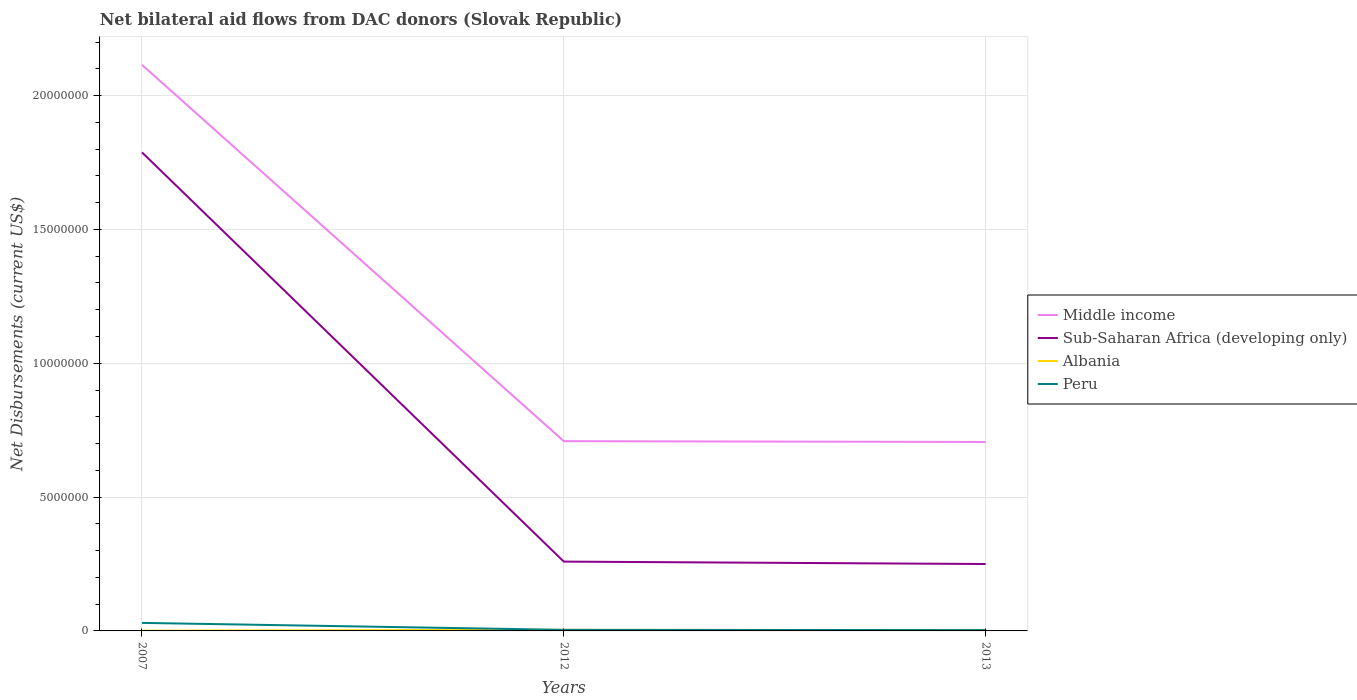How many different coloured lines are there?
Your answer should be very brief. 4. Does the line corresponding to Middle income intersect with the line corresponding to Peru?
Provide a short and direct response. No. Across all years, what is the maximum net bilateral aid flows in Sub-Saharan Africa (developing only)?
Make the answer very short. 2.50e+06. In which year was the net bilateral aid flows in Middle income maximum?
Provide a succinct answer. 2013. What is the total net bilateral aid flows in Peru in the graph?
Provide a short and direct response. 2.70e+05. What is the difference between the highest and the second highest net bilateral aid flows in Albania?
Ensure brevity in your answer.  3.00e+04. What is the difference between the highest and the lowest net bilateral aid flows in Sub-Saharan Africa (developing only)?
Provide a short and direct response. 1. How many years are there in the graph?
Your answer should be very brief. 3. Are the values on the major ticks of Y-axis written in scientific E-notation?
Offer a very short reply. No. Does the graph contain grids?
Your response must be concise. Yes. Where does the legend appear in the graph?
Offer a very short reply. Center right. How many legend labels are there?
Give a very brief answer. 4. How are the legend labels stacked?
Your response must be concise. Vertical. What is the title of the graph?
Provide a short and direct response. Net bilateral aid flows from DAC donors (Slovak Republic). What is the label or title of the X-axis?
Provide a succinct answer. Years. What is the label or title of the Y-axis?
Give a very brief answer. Net Disbursements (current US$). What is the Net Disbursements (current US$) in Middle income in 2007?
Provide a succinct answer. 2.12e+07. What is the Net Disbursements (current US$) of Sub-Saharan Africa (developing only) in 2007?
Provide a succinct answer. 1.79e+07. What is the Net Disbursements (current US$) in Peru in 2007?
Your answer should be compact. 3.00e+05. What is the Net Disbursements (current US$) of Middle income in 2012?
Offer a terse response. 7.09e+06. What is the Net Disbursements (current US$) of Sub-Saharan Africa (developing only) in 2012?
Your answer should be compact. 2.59e+06. What is the Net Disbursements (current US$) in Albania in 2012?
Provide a succinct answer. 4.00e+04. What is the Net Disbursements (current US$) of Middle income in 2013?
Offer a very short reply. 7.06e+06. What is the Net Disbursements (current US$) of Sub-Saharan Africa (developing only) in 2013?
Keep it short and to the point. 2.50e+06. Across all years, what is the maximum Net Disbursements (current US$) in Middle income?
Offer a very short reply. 2.12e+07. Across all years, what is the maximum Net Disbursements (current US$) of Sub-Saharan Africa (developing only)?
Offer a terse response. 1.79e+07. Across all years, what is the maximum Net Disbursements (current US$) of Peru?
Your response must be concise. 3.00e+05. Across all years, what is the minimum Net Disbursements (current US$) of Middle income?
Your answer should be compact. 7.06e+06. Across all years, what is the minimum Net Disbursements (current US$) of Sub-Saharan Africa (developing only)?
Your answer should be very brief. 2.50e+06. Across all years, what is the minimum Net Disbursements (current US$) of Albania?
Make the answer very short. 10000. What is the total Net Disbursements (current US$) in Middle income in the graph?
Provide a short and direct response. 3.53e+07. What is the total Net Disbursements (current US$) of Sub-Saharan Africa (developing only) in the graph?
Give a very brief answer. 2.30e+07. What is the total Net Disbursements (current US$) of Peru in the graph?
Offer a terse response. 3.70e+05. What is the difference between the Net Disbursements (current US$) of Middle income in 2007 and that in 2012?
Your response must be concise. 1.41e+07. What is the difference between the Net Disbursements (current US$) in Sub-Saharan Africa (developing only) in 2007 and that in 2012?
Offer a very short reply. 1.53e+07. What is the difference between the Net Disbursements (current US$) of Albania in 2007 and that in 2012?
Keep it short and to the point. -3.00e+04. What is the difference between the Net Disbursements (current US$) of Peru in 2007 and that in 2012?
Ensure brevity in your answer.  2.60e+05. What is the difference between the Net Disbursements (current US$) of Middle income in 2007 and that in 2013?
Ensure brevity in your answer.  1.41e+07. What is the difference between the Net Disbursements (current US$) of Sub-Saharan Africa (developing only) in 2007 and that in 2013?
Your response must be concise. 1.54e+07. What is the difference between the Net Disbursements (current US$) in Albania in 2007 and that in 2013?
Ensure brevity in your answer.  -2.00e+04. What is the difference between the Net Disbursements (current US$) in Peru in 2007 and that in 2013?
Your answer should be very brief. 2.70e+05. What is the difference between the Net Disbursements (current US$) of Middle income in 2012 and that in 2013?
Give a very brief answer. 3.00e+04. What is the difference between the Net Disbursements (current US$) in Middle income in 2007 and the Net Disbursements (current US$) in Sub-Saharan Africa (developing only) in 2012?
Provide a succinct answer. 1.86e+07. What is the difference between the Net Disbursements (current US$) of Middle income in 2007 and the Net Disbursements (current US$) of Albania in 2012?
Provide a short and direct response. 2.11e+07. What is the difference between the Net Disbursements (current US$) of Middle income in 2007 and the Net Disbursements (current US$) of Peru in 2012?
Your answer should be compact. 2.11e+07. What is the difference between the Net Disbursements (current US$) of Sub-Saharan Africa (developing only) in 2007 and the Net Disbursements (current US$) of Albania in 2012?
Your response must be concise. 1.78e+07. What is the difference between the Net Disbursements (current US$) of Sub-Saharan Africa (developing only) in 2007 and the Net Disbursements (current US$) of Peru in 2012?
Your response must be concise. 1.78e+07. What is the difference between the Net Disbursements (current US$) in Albania in 2007 and the Net Disbursements (current US$) in Peru in 2012?
Your response must be concise. -3.00e+04. What is the difference between the Net Disbursements (current US$) of Middle income in 2007 and the Net Disbursements (current US$) of Sub-Saharan Africa (developing only) in 2013?
Your answer should be very brief. 1.86e+07. What is the difference between the Net Disbursements (current US$) of Middle income in 2007 and the Net Disbursements (current US$) of Albania in 2013?
Provide a short and direct response. 2.11e+07. What is the difference between the Net Disbursements (current US$) in Middle income in 2007 and the Net Disbursements (current US$) in Peru in 2013?
Make the answer very short. 2.11e+07. What is the difference between the Net Disbursements (current US$) of Sub-Saharan Africa (developing only) in 2007 and the Net Disbursements (current US$) of Albania in 2013?
Your answer should be very brief. 1.78e+07. What is the difference between the Net Disbursements (current US$) in Sub-Saharan Africa (developing only) in 2007 and the Net Disbursements (current US$) in Peru in 2013?
Your response must be concise. 1.78e+07. What is the difference between the Net Disbursements (current US$) in Albania in 2007 and the Net Disbursements (current US$) in Peru in 2013?
Your response must be concise. -2.00e+04. What is the difference between the Net Disbursements (current US$) of Middle income in 2012 and the Net Disbursements (current US$) of Sub-Saharan Africa (developing only) in 2013?
Provide a short and direct response. 4.59e+06. What is the difference between the Net Disbursements (current US$) in Middle income in 2012 and the Net Disbursements (current US$) in Albania in 2013?
Offer a very short reply. 7.06e+06. What is the difference between the Net Disbursements (current US$) in Middle income in 2012 and the Net Disbursements (current US$) in Peru in 2013?
Ensure brevity in your answer.  7.06e+06. What is the difference between the Net Disbursements (current US$) of Sub-Saharan Africa (developing only) in 2012 and the Net Disbursements (current US$) of Albania in 2013?
Offer a terse response. 2.56e+06. What is the difference between the Net Disbursements (current US$) of Sub-Saharan Africa (developing only) in 2012 and the Net Disbursements (current US$) of Peru in 2013?
Keep it short and to the point. 2.56e+06. What is the average Net Disbursements (current US$) in Middle income per year?
Provide a short and direct response. 1.18e+07. What is the average Net Disbursements (current US$) in Sub-Saharan Africa (developing only) per year?
Your answer should be very brief. 7.66e+06. What is the average Net Disbursements (current US$) in Albania per year?
Provide a succinct answer. 2.67e+04. What is the average Net Disbursements (current US$) of Peru per year?
Keep it short and to the point. 1.23e+05. In the year 2007, what is the difference between the Net Disbursements (current US$) in Middle income and Net Disbursements (current US$) in Sub-Saharan Africa (developing only)?
Provide a short and direct response. 3.27e+06. In the year 2007, what is the difference between the Net Disbursements (current US$) of Middle income and Net Disbursements (current US$) of Albania?
Your answer should be compact. 2.11e+07. In the year 2007, what is the difference between the Net Disbursements (current US$) in Middle income and Net Disbursements (current US$) in Peru?
Ensure brevity in your answer.  2.08e+07. In the year 2007, what is the difference between the Net Disbursements (current US$) in Sub-Saharan Africa (developing only) and Net Disbursements (current US$) in Albania?
Your response must be concise. 1.79e+07. In the year 2007, what is the difference between the Net Disbursements (current US$) in Sub-Saharan Africa (developing only) and Net Disbursements (current US$) in Peru?
Make the answer very short. 1.76e+07. In the year 2012, what is the difference between the Net Disbursements (current US$) of Middle income and Net Disbursements (current US$) of Sub-Saharan Africa (developing only)?
Offer a very short reply. 4.50e+06. In the year 2012, what is the difference between the Net Disbursements (current US$) of Middle income and Net Disbursements (current US$) of Albania?
Provide a succinct answer. 7.05e+06. In the year 2012, what is the difference between the Net Disbursements (current US$) of Middle income and Net Disbursements (current US$) of Peru?
Offer a terse response. 7.05e+06. In the year 2012, what is the difference between the Net Disbursements (current US$) in Sub-Saharan Africa (developing only) and Net Disbursements (current US$) in Albania?
Make the answer very short. 2.55e+06. In the year 2012, what is the difference between the Net Disbursements (current US$) in Sub-Saharan Africa (developing only) and Net Disbursements (current US$) in Peru?
Give a very brief answer. 2.55e+06. In the year 2012, what is the difference between the Net Disbursements (current US$) in Albania and Net Disbursements (current US$) in Peru?
Offer a terse response. 0. In the year 2013, what is the difference between the Net Disbursements (current US$) of Middle income and Net Disbursements (current US$) of Sub-Saharan Africa (developing only)?
Ensure brevity in your answer.  4.56e+06. In the year 2013, what is the difference between the Net Disbursements (current US$) in Middle income and Net Disbursements (current US$) in Albania?
Keep it short and to the point. 7.03e+06. In the year 2013, what is the difference between the Net Disbursements (current US$) in Middle income and Net Disbursements (current US$) in Peru?
Your answer should be compact. 7.03e+06. In the year 2013, what is the difference between the Net Disbursements (current US$) of Sub-Saharan Africa (developing only) and Net Disbursements (current US$) of Albania?
Your response must be concise. 2.47e+06. In the year 2013, what is the difference between the Net Disbursements (current US$) of Sub-Saharan Africa (developing only) and Net Disbursements (current US$) of Peru?
Provide a short and direct response. 2.47e+06. What is the ratio of the Net Disbursements (current US$) in Middle income in 2007 to that in 2012?
Keep it short and to the point. 2.98. What is the ratio of the Net Disbursements (current US$) of Sub-Saharan Africa (developing only) in 2007 to that in 2012?
Your answer should be compact. 6.9. What is the ratio of the Net Disbursements (current US$) of Albania in 2007 to that in 2012?
Make the answer very short. 0.25. What is the ratio of the Net Disbursements (current US$) of Peru in 2007 to that in 2012?
Your answer should be very brief. 7.5. What is the ratio of the Net Disbursements (current US$) of Middle income in 2007 to that in 2013?
Make the answer very short. 3. What is the ratio of the Net Disbursements (current US$) in Sub-Saharan Africa (developing only) in 2007 to that in 2013?
Keep it short and to the point. 7.15. What is the ratio of the Net Disbursements (current US$) of Albania in 2007 to that in 2013?
Offer a very short reply. 0.33. What is the ratio of the Net Disbursements (current US$) in Middle income in 2012 to that in 2013?
Ensure brevity in your answer.  1. What is the ratio of the Net Disbursements (current US$) in Sub-Saharan Africa (developing only) in 2012 to that in 2013?
Offer a terse response. 1.04. What is the ratio of the Net Disbursements (current US$) in Peru in 2012 to that in 2013?
Make the answer very short. 1.33. What is the difference between the highest and the second highest Net Disbursements (current US$) of Middle income?
Make the answer very short. 1.41e+07. What is the difference between the highest and the second highest Net Disbursements (current US$) of Sub-Saharan Africa (developing only)?
Provide a succinct answer. 1.53e+07. What is the difference between the highest and the lowest Net Disbursements (current US$) in Middle income?
Offer a terse response. 1.41e+07. What is the difference between the highest and the lowest Net Disbursements (current US$) in Sub-Saharan Africa (developing only)?
Offer a terse response. 1.54e+07. What is the difference between the highest and the lowest Net Disbursements (current US$) of Peru?
Give a very brief answer. 2.70e+05. 